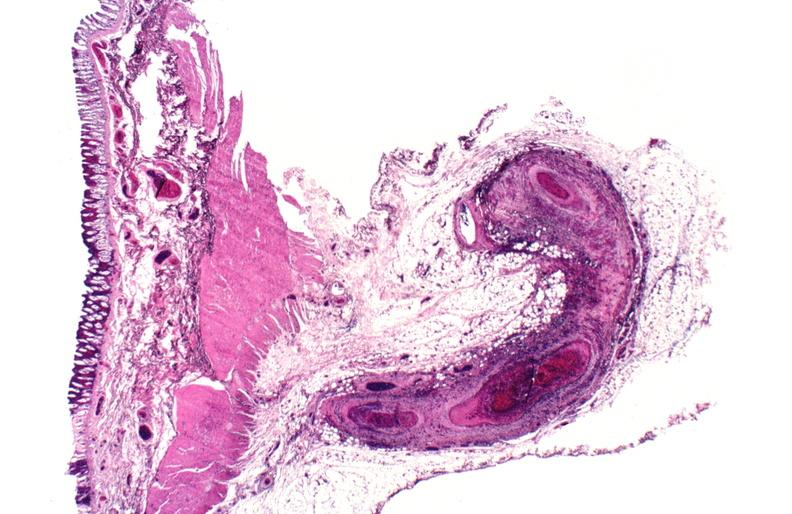what is present?
Answer the question using a single word or phrase. Vasculature 